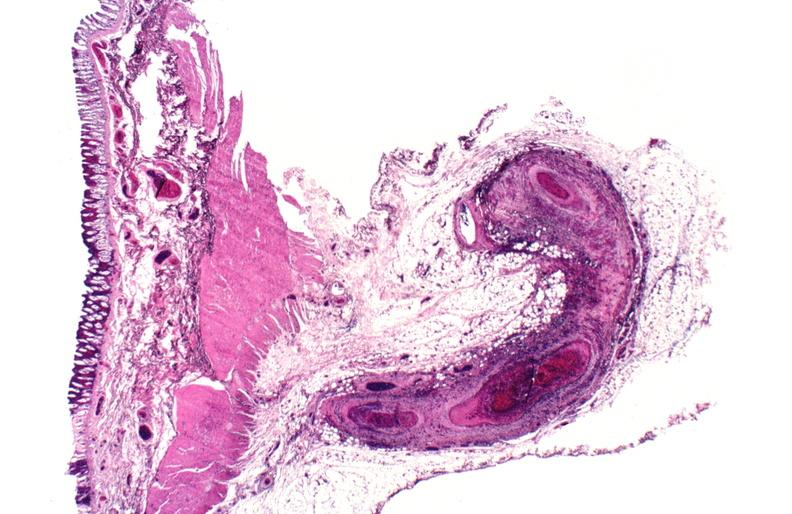what is present?
Answer the question using a single word or phrase. Vasculature 